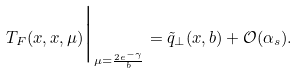<formula> <loc_0><loc_0><loc_500><loc_500>T _ { F } ( x , x , \mu ) \Big | _ { \mu = \frac { 2 e ^ { - \gamma } } { b } } = \tilde { q } _ { \perp } ( x , b ) + { \mathcal { O } } ( \alpha _ { s } ) .</formula> 